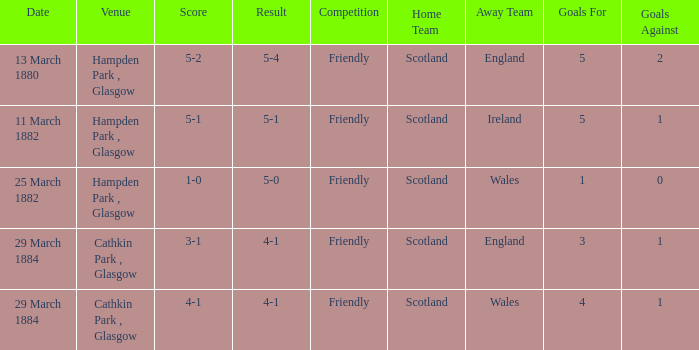Which competition had a 4-1 result, and a score of 4-1? Friendly. 